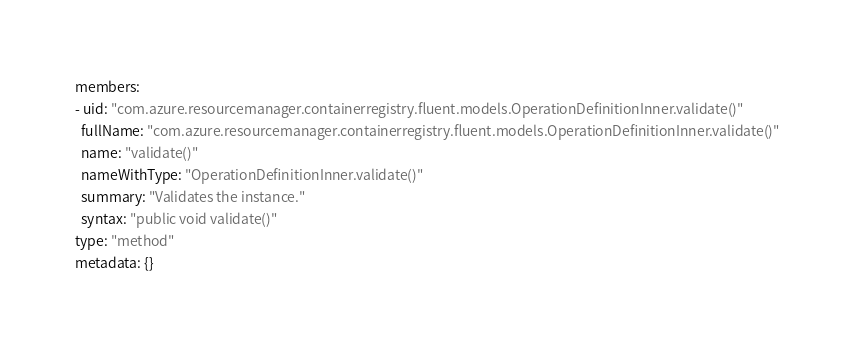<code> <loc_0><loc_0><loc_500><loc_500><_YAML_>members:
- uid: "com.azure.resourcemanager.containerregistry.fluent.models.OperationDefinitionInner.validate()"
  fullName: "com.azure.resourcemanager.containerregistry.fluent.models.OperationDefinitionInner.validate()"
  name: "validate()"
  nameWithType: "OperationDefinitionInner.validate()"
  summary: "Validates the instance."
  syntax: "public void validate()"
type: "method"
metadata: {}</code> 